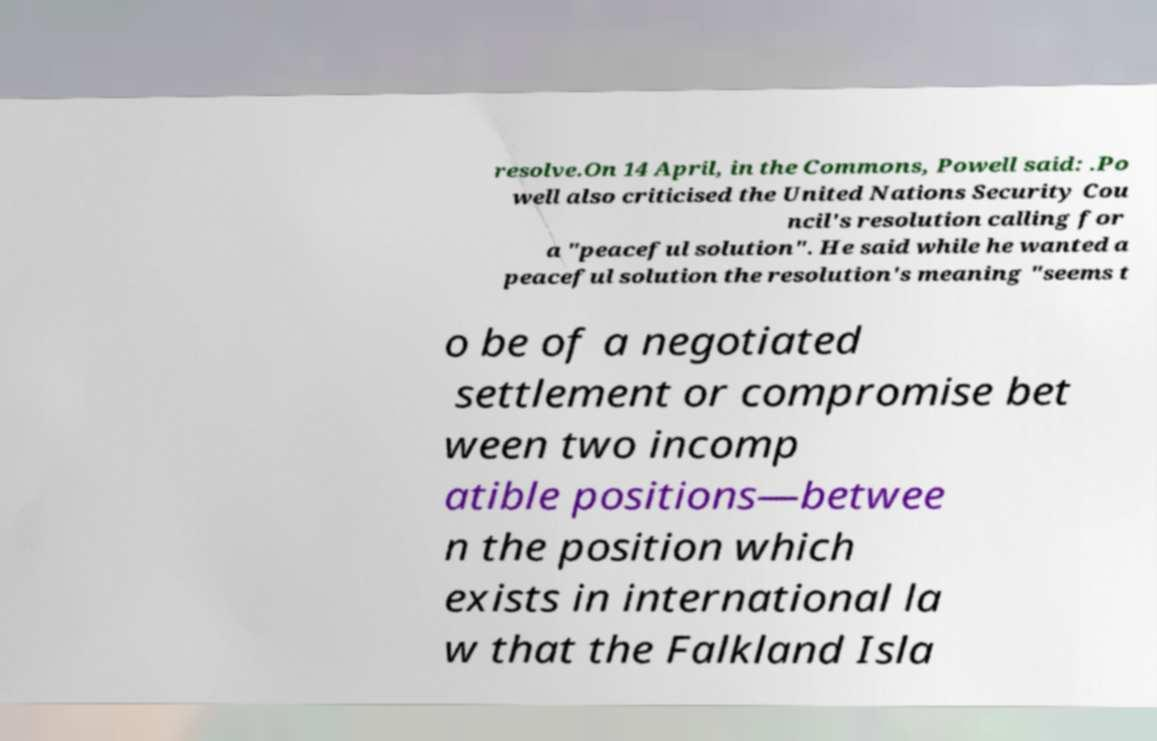Please identify and transcribe the text found in this image. resolve.On 14 April, in the Commons, Powell said: .Po well also criticised the United Nations Security Cou ncil's resolution calling for a "peaceful solution". He said while he wanted a peaceful solution the resolution's meaning "seems t o be of a negotiated settlement or compromise bet ween two incomp atible positions—betwee n the position which exists in international la w that the Falkland Isla 